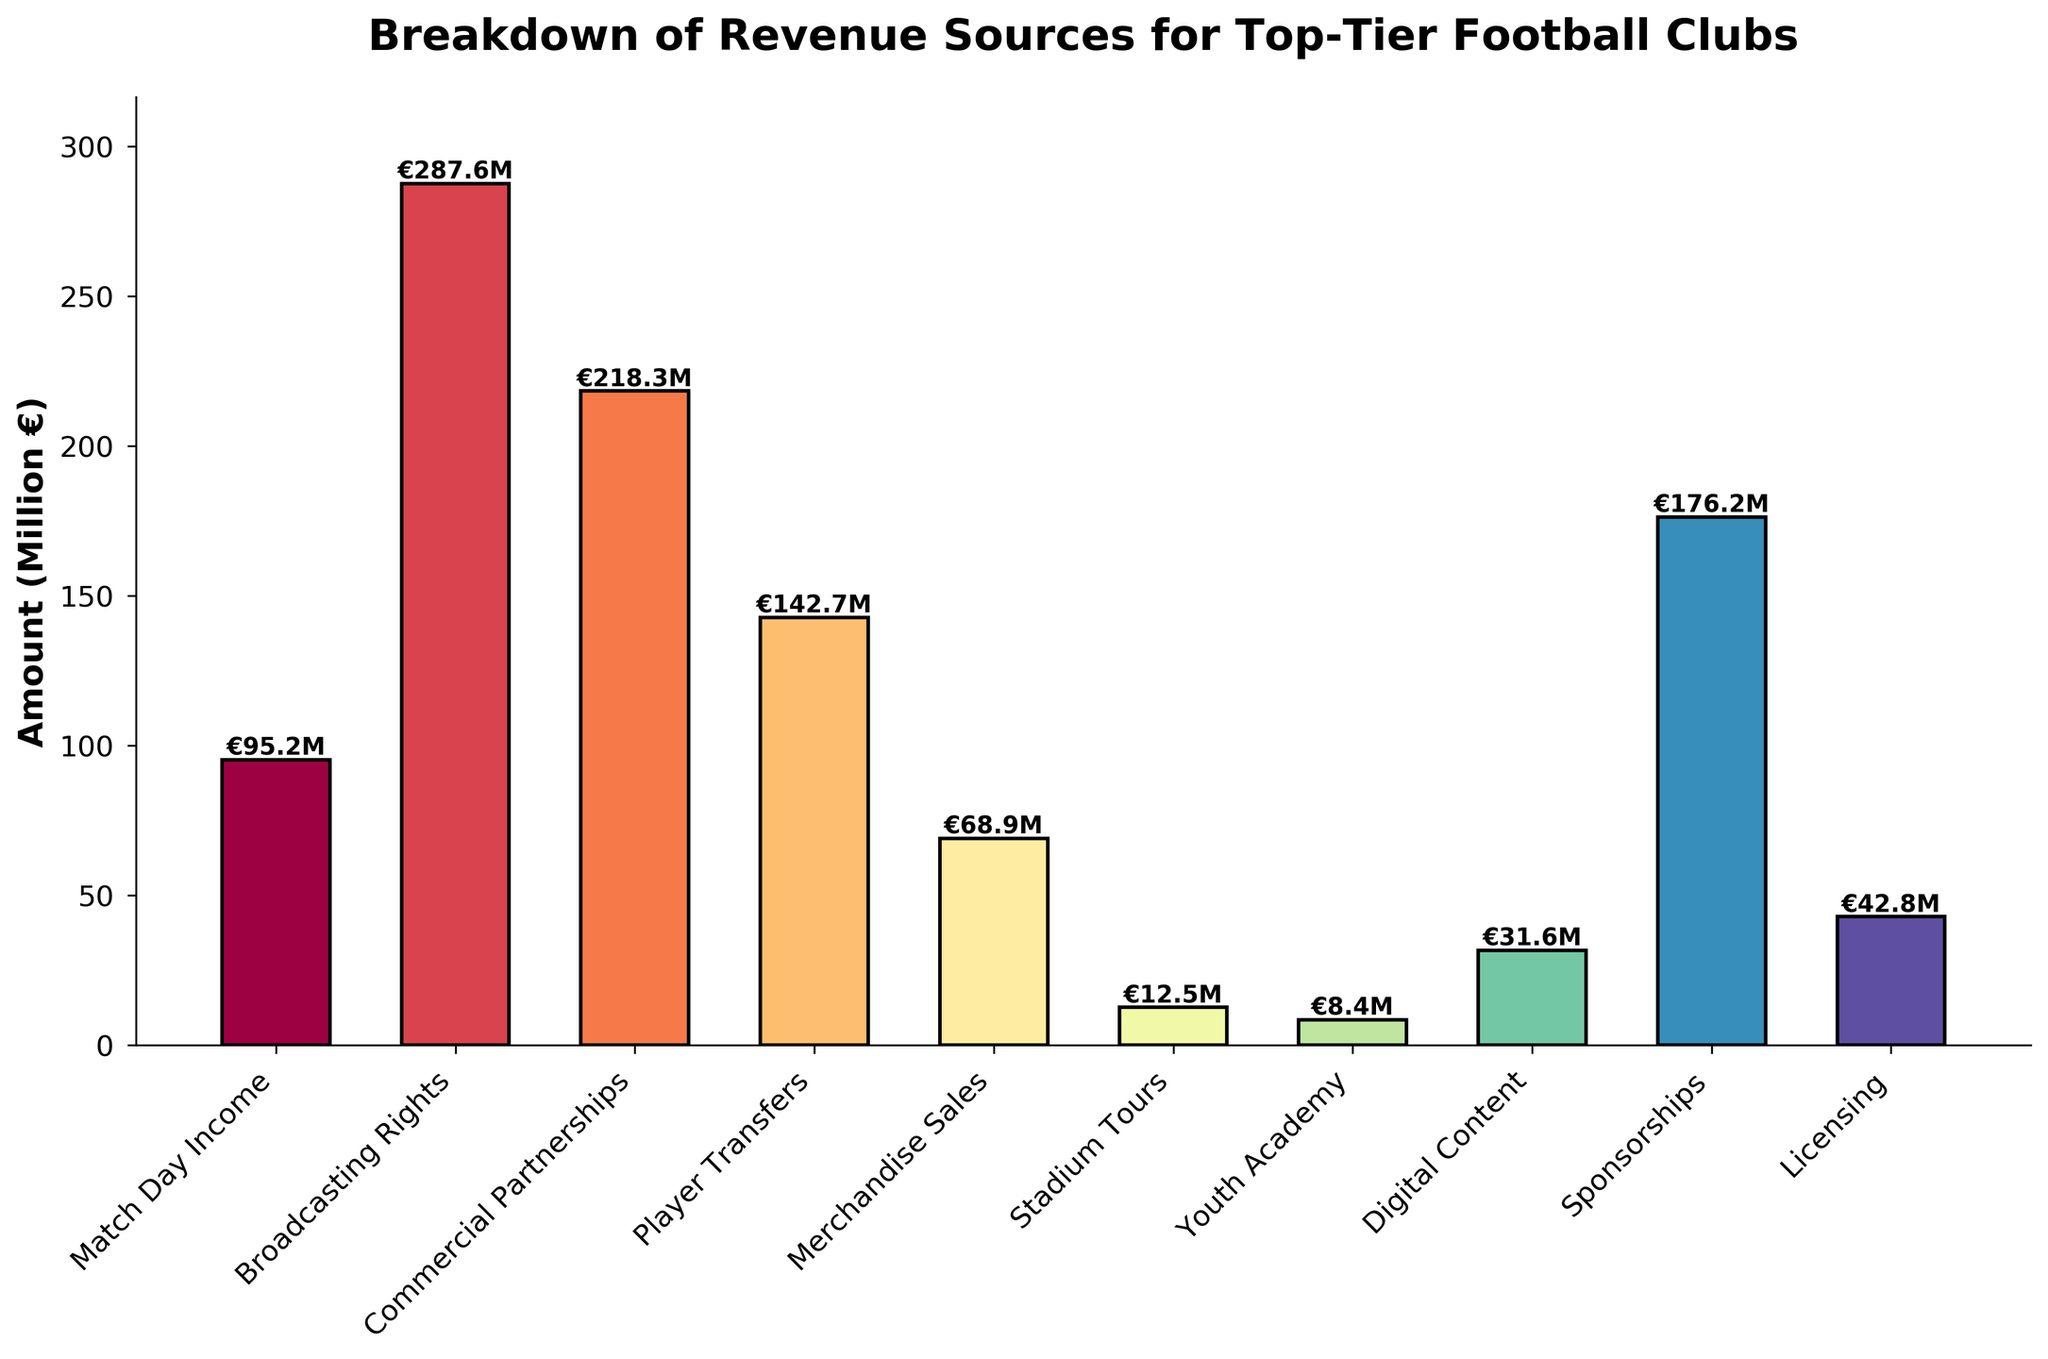Which revenue source brings in the highest amount? By looking at the height of the bars, the tallest bar represents the revenue source that brings in the highest amount. The Broadcasting Rights bar is the tallest.
Answer: Broadcasting Rights Which revenue source contributes the least to the revenue? Observing the shortest bar on the chart, it indicates the revenue source with the least contribution. The Youth Academy bar is the shortest.
Answer: Youth Academy What is the total revenue from Broadcasting Rights and Sponsorships combined? Add the amounts from Broadcasting Rights and Sponsorships: 287.6 + 176.2 = 463.8 million €.
Answer: 463.8 million € Which has a greater revenue contribution, Merchandise Sales or Digital Content? By how much? Compare the heights of the bars for Merchandise Sales and Digital Content. Merchandise Sales (68.9) is higher than Digital Content (31.6). Subtract Digital Content from Merchandise Sales: 68.9 - 31.6 = 37.3 million €.
Answer: Merchandise Sales by 37.3 million € What is the sum of revenue from Match Day Income, Stadium Tours, and Youth Academy? Add the amounts from Match Day Income, Stadium Tours, and Youth Academy: 95.2 + 12.5 + 8.4 = 116.1 million €.
Answer: 116.1 million € What percentage of the total revenue comes from Commercial Partnerships? Calculate the total revenue by summing all sources, then find the percentage of Commercial Partnerships out of the total: 
Total = 95.2 + 287.6 + 218.3 + 142.7 + 68.9 + 12.5 + 8.4 + 31.6 + 176.2 + 42.8 = 1084.2 million € 
Percentage = (218.3 / 1084.2) * 100 ≈ 20.1%
Answer: 20.1% Is the sum of revenue from Player Transfers and Licensing greater than that from Match Day Income and Broadcasting Rights? Calculate the sums and compare: 
Player Transfers + Licensing = 142.7 + 42.8 = 185.5 million €
Match Day Income + Broadcasting Rights = 95.2 + 287.6 = 382.8 million €
185.5 < 382.8
Answer: No If revenues from Digital Content doubled, how would its new contribution compare to that of Licensing? Double the amount from Digital Content: 2 * 31.6 = 63.2 million €. Compare it to Licensing (42.8 million €). 63.2 > 42.8, so Digital Content would become higher.
Answer: Digital Content would be higher Which three revenue sources have the closest amounts, and what are their values? Look for bars with similar heights. The revenue sources that are closest in values are Licensing (€42.8M), Digital Content (€31.6M), and Merchandise Sales (€68.9M).
Answer: Licensing (€42.8M), Digital Content (€31.6M), and Merchandise Sales (€68.9M) 